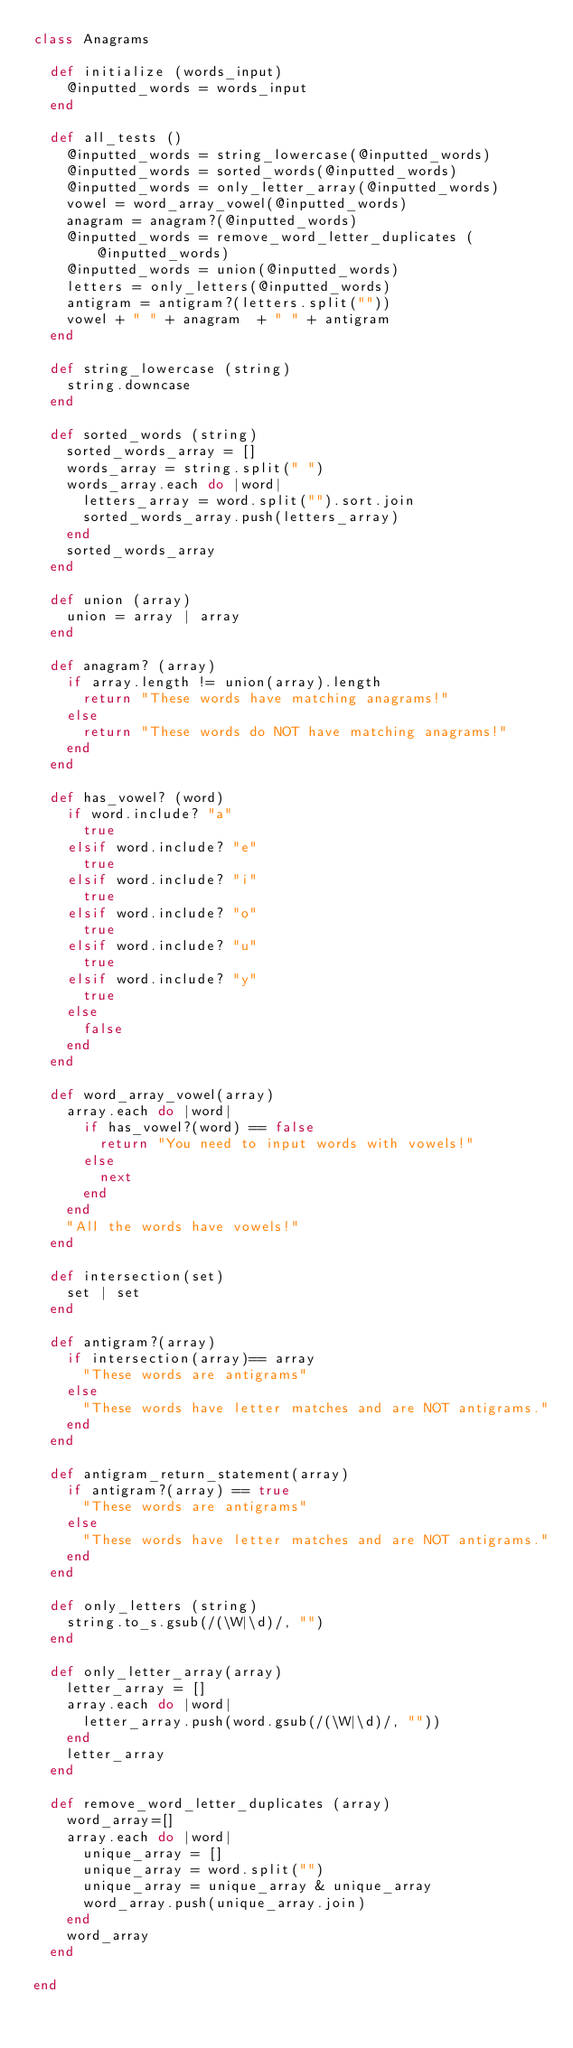Convert code to text. <code><loc_0><loc_0><loc_500><loc_500><_Ruby_>class Anagrams

  def initialize (words_input)
    @inputted_words = words_input
  end

  def all_tests ()
    @inputted_words = string_lowercase(@inputted_words)
    @inputted_words = sorted_words(@inputted_words)
    @inputted_words = only_letter_array(@inputted_words)
    vowel = word_array_vowel(@inputted_words)
    anagram = anagram?(@inputted_words)
    @inputted_words = remove_word_letter_duplicates (@inputted_words)
    @inputted_words = union(@inputted_words)
    letters = only_letters(@inputted_words)
    antigram = antigram?(letters.split(""))
    vowel + " " + anagram  + " " + antigram
  end

  def string_lowercase (string)
    string.downcase
  end

  def sorted_words (string)
    sorted_words_array = []
    words_array = string.split(" ")
    words_array.each do |word|
      letters_array = word.split("").sort.join
      sorted_words_array.push(letters_array)
    end
    sorted_words_array
  end

  def union (array)
    union = array | array
  end

  def anagram? (array)
    if array.length != union(array).length
      return "These words have matching anagrams!"
    else
      return "These words do NOT have matching anagrams!"
    end
  end

  def has_vowel? (word)
    if word.include? "a"
      true
    elsif word.include? "e"
      true
    elsif word.include? "i"
      true
    elsif word.include? "o"
      true
    elsif word.include? "u"
      true
    elsif word.include? "y"
      true
    else
      false
    end
  end

  def word_array_vowel(array)
    array.each do |word|
      if has_vowel?(word) == false
        return "You need to input words with vowels!"
      else
        next
      end
    end
    "All the words have vowels!"
  end

  def intersection(set)
    set | set
  end

  def antigram?(array)
    if intersection(array)== array
      "These words are antigrams"
    else
      "These words have letter matches and are NOT antigrams."
    end
  end

  def antigram_return_statement(array)
    if antigram?(array) == true
      "These words are antigrams"
    else
      "These words have letter matches and are NOT antigrams."
    end
  end

  def only_letters (string)
    string.to_s.gsub(/(\W|\d)/, "")
  end

  def only_letter_array(array)
    letter_array = []
    array.each do |word|
      letter_array.push(word.gsub(/(\W|\d)/, ""))
    end
    letter_array
  end

  def remove_word_letter_duplicates (array)
    word_array=[]
    array.each do |word|
      unique_array = []
      unique_array = word.split("")
      unique_array = unique_array & unique_array
      word_array.push(unique_array.join)
    end
    word_array
  end

end
</code> 